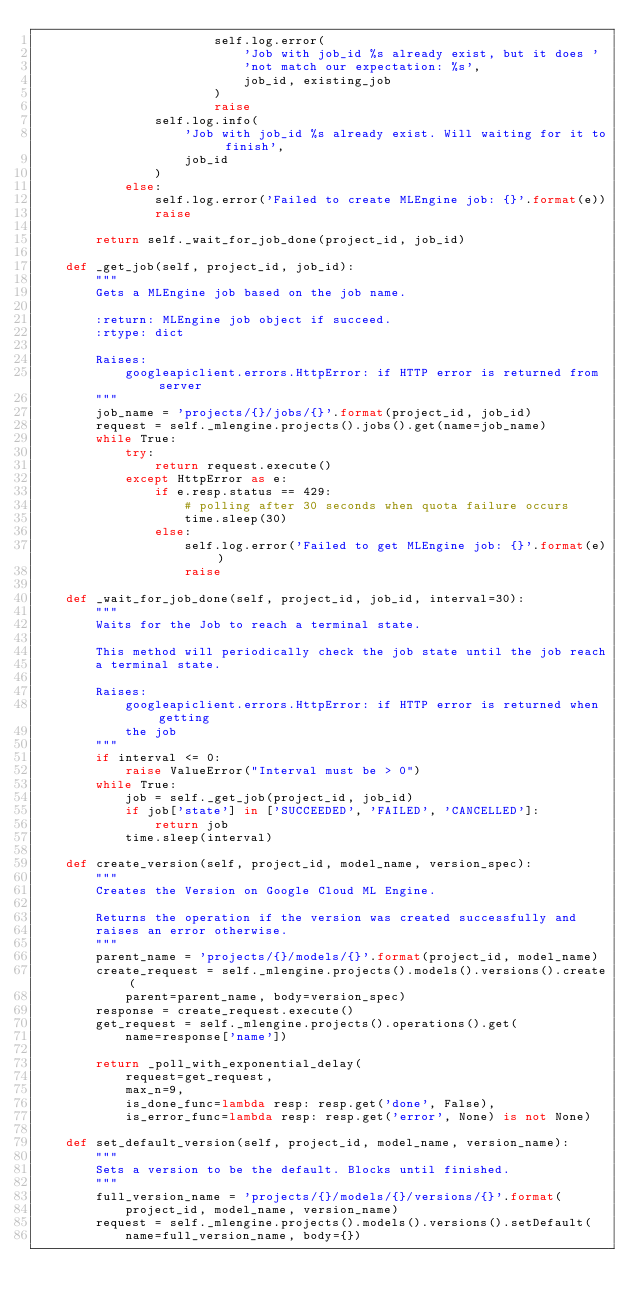<code> <loc_0><loc_0><loc_500><loc_500><_Python_>                        self.log.error(
                            'Job with job_id %s already exist, but it does '
                            'not match our expectation: %s',
                            job_id, existing_job
                        )
                        raise
                self.log.info(
                    'Job with job_id %s already exist. Will waiting for it to finish',
                    job_id
                )
            else:
                self.log.error('Failed to create MLEngine job: {}'.format(e))
                raise

        return self._wait_for_job_done(project_id, job_id)

    def _get_job(self, project_id, job_id):
        """
        Gets a MLEngine job based on the job name.

        :return: MLEngine job object if succeed.
        :rtype: dict

        Raises:
            googleapiclient.errors.HttpError: if HTTP error is returned from server
        """
        job_name = 'projects/{}/jobs/{}'.format(project_id, job_id)
        request = self._mlengine.projects().jobs().get(name=job_name)
        while True:
            try:
                return request.execute()
            except HttpError as e:
                if e.resp.status == 429:
                    # polling after 30 seconds when quota failure occurs
                    time.sleep(30)
                else:
                    self.log.error('Failed to get MLEngine job: {}'.format(e))
                    raise

    def _wait_for_job_done(self, project_id, job_id, interval=30):
        """
        Waits for the Job to reach a terminal state.

        This method will periodically check the job state until the job reach
        a terminal state.

        Raises:
            googleapiclient.errors.HttpError: if HTTP error is returned when getting
            the job
        """
        if interval <= 0:
            raise ValueError("Interval must be > 0")
        while True:
            job = self._get_job(project_id, job_id)
            if job['state'] in ['SUCCEEDED', 'FAILED', 'CANCELLED']:
                return job
            time.sleep(interval)

    def create_version(self, project_id, model_name, version_spec):
        """
        Creates the Version on Google Cloud ML Engine.

        Returns the operation if the version was created successfully and
        raises an error otherwise.
        """
        parent_name = 'projects/{}/models/{}'.format(project_id, model_name)
        create_request = self._mlengine.projects().models().versions().create(
            parent=parent_name, body=version_spec)
        response = create_request.execute()
        get_request = self._mlengine.projects().operations().get(
            name=response['name'])

        return _poll_with_exponential_delay(
            request=get_request,
            max_n=9,
            is_done_func=lambda resp: resp.get('done', False),
            is_error_func=lambda resp: resp.get('error', None) is not None)

    def set_default_version(self, project_id, model_name, version_name):
        """
        Sets a version to be the default. Blocks until finished.
        """
        full_version_name = 'projects/{}/models/{}/versions/{}'.format(
            project_id, model_name, version_name)
        request = self._mlengine.projects().models().versions().setDefault(
            name=full_version_name, body={})
</code> 